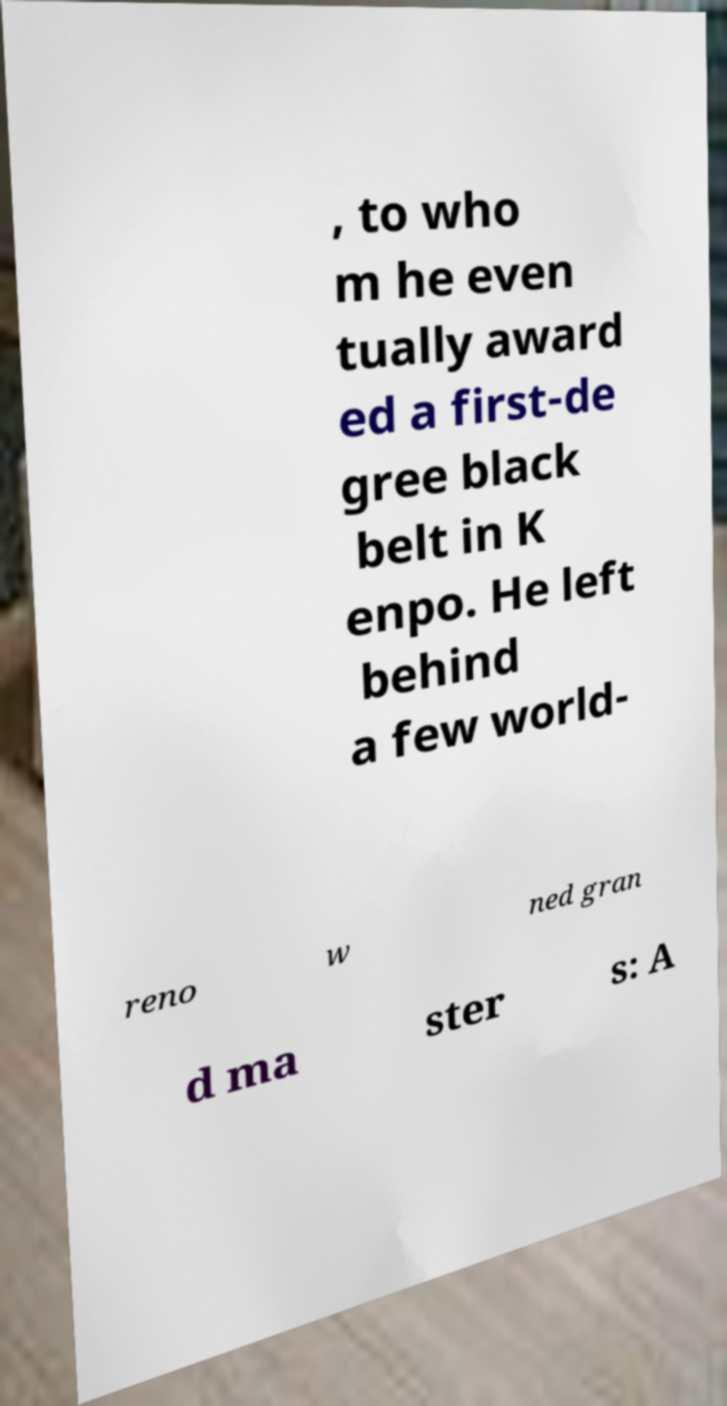For documentation purposes, I need the text within this image transcribed. Could you provide that? , to who m he even tually award ed a first-de gree black belt in K enpo. He left behind a few world- reno w ned gran d ma ster s: A 